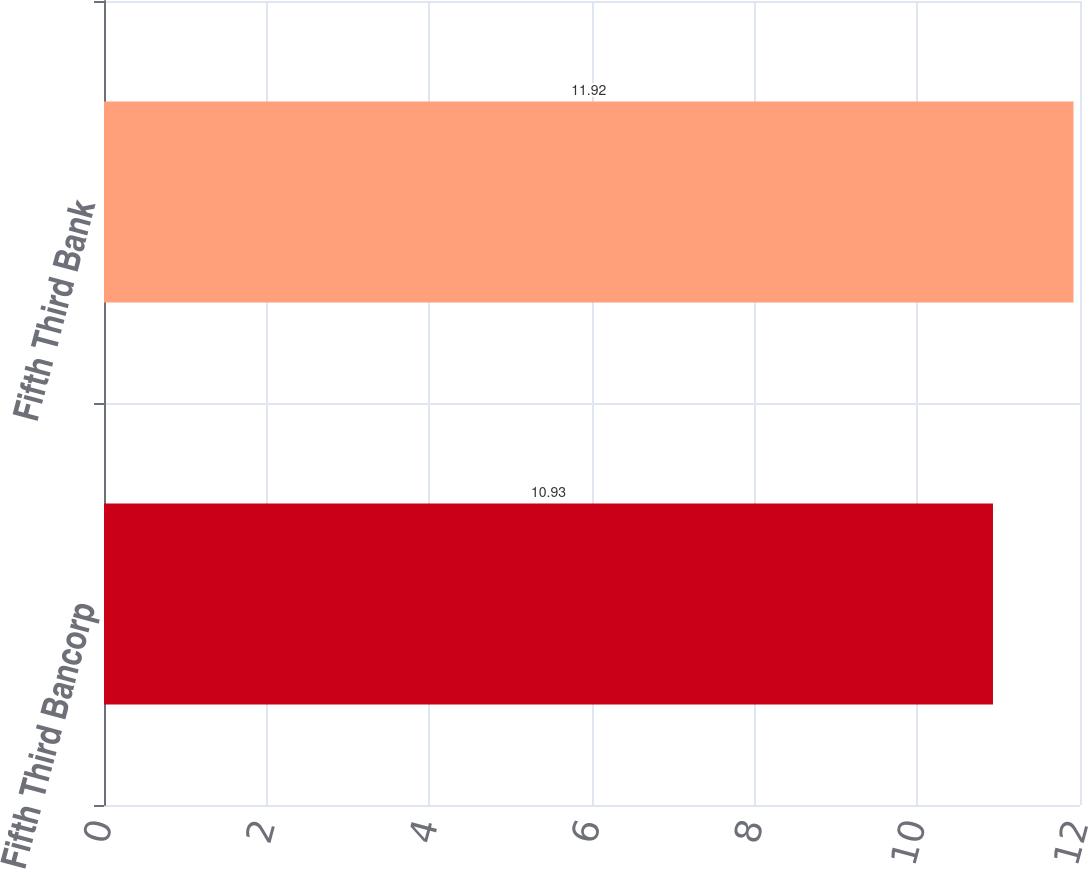<chart> <loc_0><loc_0><loc_500><loc_500><bar_chart><fcel>Fifth Third Bancorp<fcel>Fifth Third Bank<nl><fcel>10.93<fcel>11.92<nl></chart> 